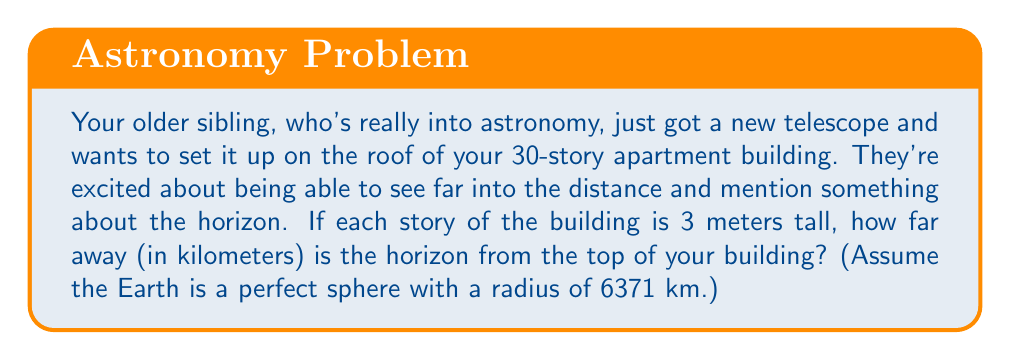Help me with this question. Let's approach this step-by-step:

1) First, we need to calculate the height of the building:
   $$ h = 30 \text{ stories} \times 3 \text{ meters/story} = 90 \text{ meters} $$

2) Now, we can use the formula for the distance to the horizon:
   $$ d = \sqrt{2Rh + h^2} $$
   where $d$ is the distance to the horizon, $R$ is the radius of the Earth, and $h$ is the height of the observer above the surface.

3) Let's plug in our values:
   $$ d = \sqrt{2 \times 6371000 \text{ m} \times 90 \text{ m} + (90 \text{ m})^2} $$

4) Simplify inside the square root:
   $$ d = \sqrt{1146780000 \text{ m}^2 + 8100 \text{ m}^2} $$
   $$ d = \sqrt{1146788100 \text{ m}^2} $$

5) Calculate:
   $$ d \approx 33863 \text{ meters} $$

6) Convert to kilometers:
   $$ d \approx 33.86 \text{ km} $$

[asy]
import geometry;

unitsize(1cm);

pair O = (0,0);
real R = 5;
real h = 0.7;
pair A = (0,R);
pair B = (0,R+h);
pair C = (sqrt(2R*h+h^2),R);

draw(Circle(O,R));
draw(A--B--C--cycle);

label("Earth's surface", (3,-3), E);
label("Eye level", B, W);
label("Horizon", C, E);
label("R", (0,R/2), W);
label("h", (0,R+h/2), E);
label("d", (sqrt(2R*h+h^2)/2,R), S);

[/asy]
Answer: $$ 33.86 \text{ km} $$ 